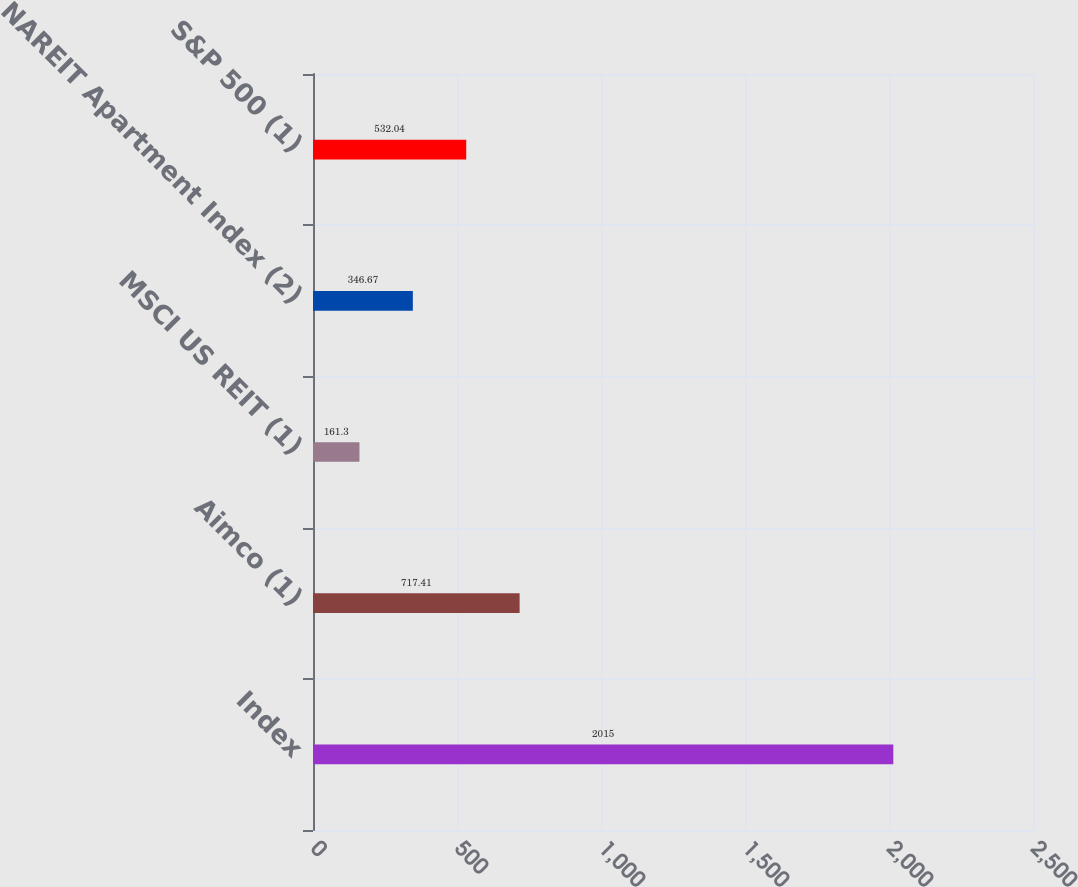<chart> <loc_0><loc_0><loc_500><loc_500><bar_chart><fcel>Index<fcel>Aimco (1)<fcel>MSCI US REIT (1)<fcel>NAREIT Apartment Index (2)<fcel>S&P 500 (1)<nl><fcel>2015<fcel>717.41<fcel>161.3<fcel>346.67<fcel>532.04<nl></chart> 